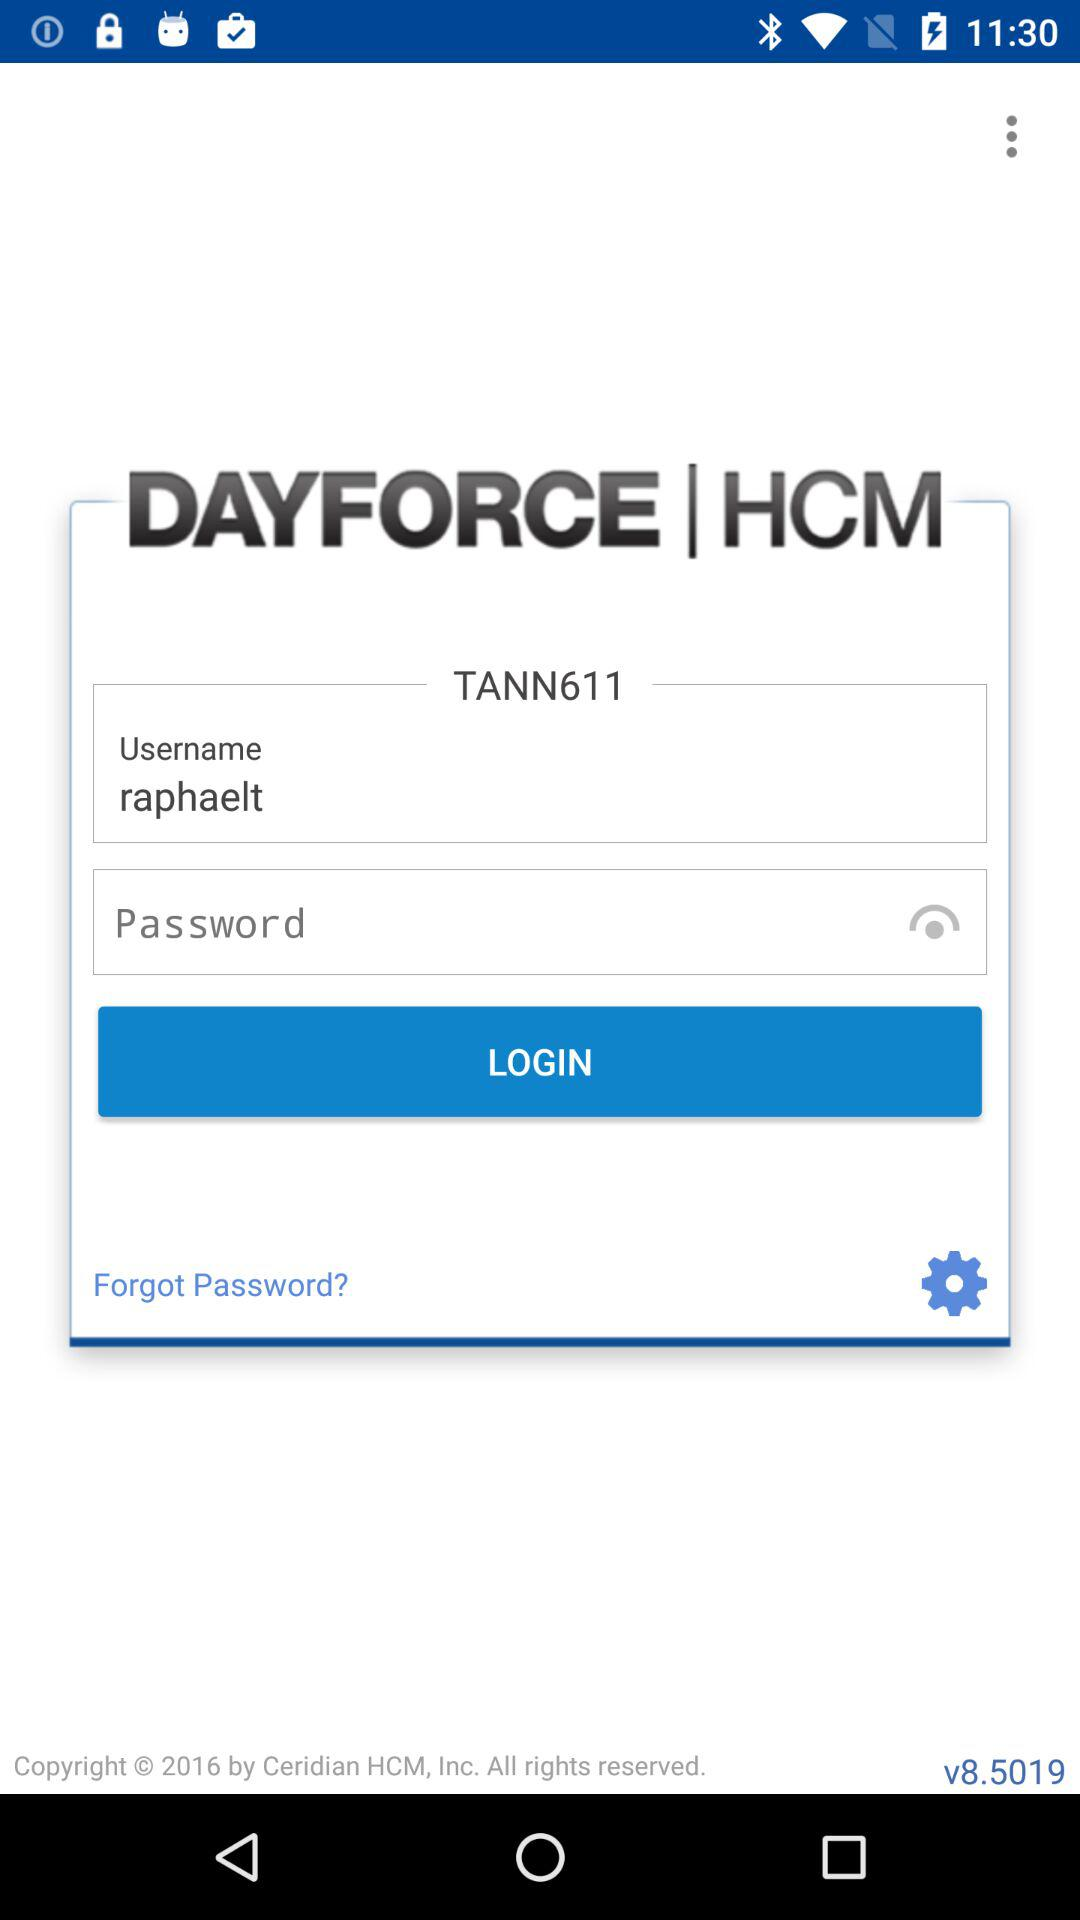What are the requirements for the password?
When the provided information is insufficient, respond with <no answer>. <no answer> 